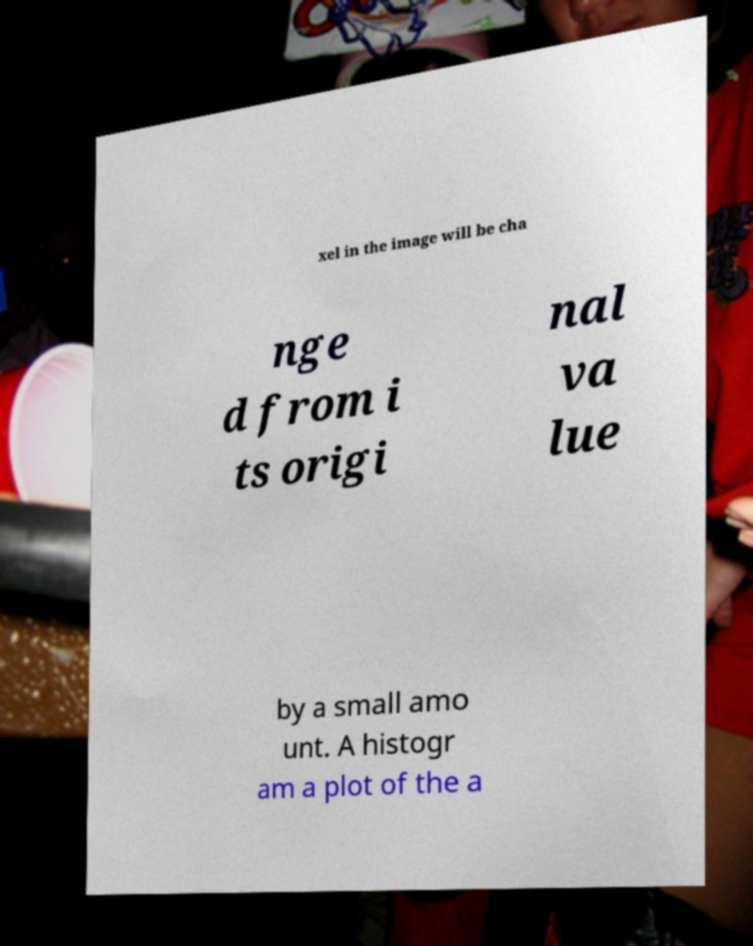Can you read and provide the text displayed in the image?This photo seems to have some interesting text. Can you extract and type it out for me? xel in the image will be cha nge d from i ts origi nal va lue by a small amo unt. A histogr am a plot of the a 